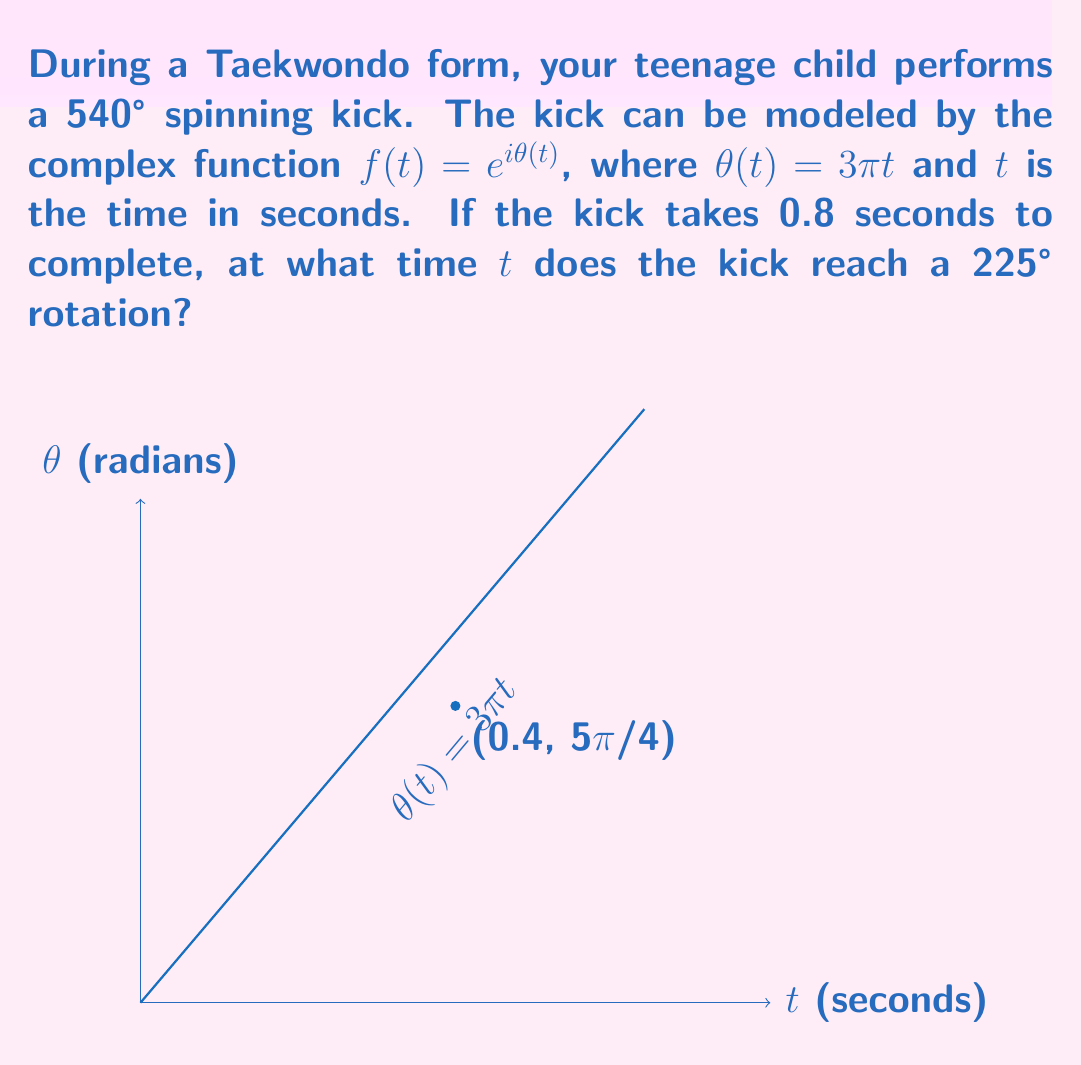Provide a solution to this math problem. Let's approach this step-by-step:

1) We know that $\theta(t) = 3\pi t$ and we're looking for the time when the rotation reaches 225°.

2) First, let's convert 225° to radians:
   $225° = 225 \cdot \frac{\pi}{180} = \frac{5\pi}{4}$ radians

3) Now, we can set up an equation:
   $\theta(t) = \frac{5\pi}{4}$

4) Substituting the given function:
   $3\pi t = \frac{5\pi}{4}$

5) Solving for $t$:
   $t = \frac{5\pi}{4} \cdot \frac{1}{3\pi} = \frac{5}{12} \approx 0.4167$ seconds

6) We can verify that this is less than the total time of 0.8 seconds, so it's a valid solution.

The graph in the question visualizes this solution, showing the linear relationship between time and rotation angle, with the point (0.4, 5π/4) marked.
Answer: $t = \frac{5}{12}$ seconds 